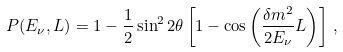<formula> <loc_0><loc_0><loc_500><loc_500>P ( E _ { \nu } , L ) = 1 - \frac { 1 } { 2 } \sin ^ { 2 } 2 \theta \left [ 1 - \cos \left ( \frac { \delta m ^ { 2 } } { 2 E _ { \nu } } L \right ) \right ] \, ,</formula> 